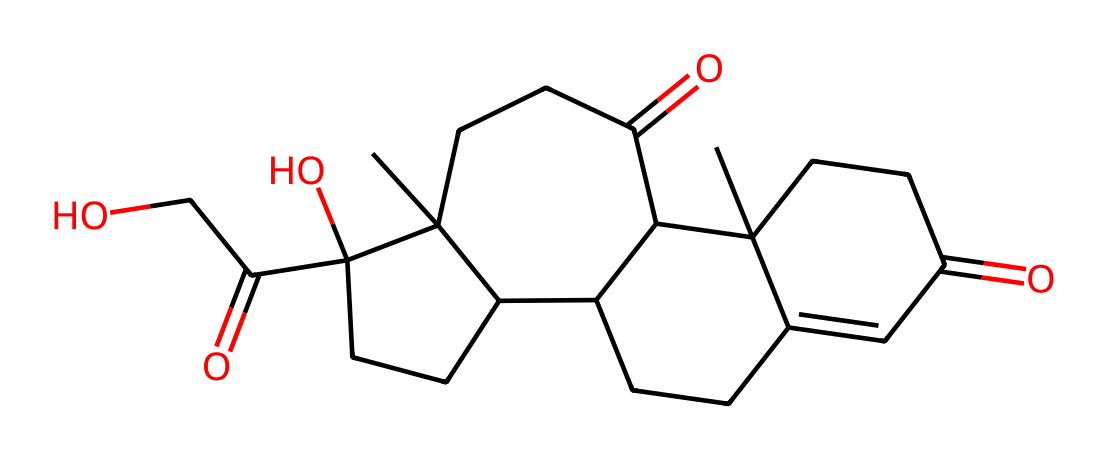What is the name of this chemical? The chemical structure represented by the provided SMILES corresponds to cortisol, which is known as a glucocorticoid hormone.
Answer: cortisol How many carbon atoms are present in the structure? By analyzing the SMILES, we can count that there are 21 carbon (C) atoms present in the structure of cortisol.
Answer: 21 What type of chemical compound is cortisol? Cortisol is classified as a steroid hormone due to its specific structural features, including its four fused carbon rings.
Answer: steroid hormone What functional groups are present in cortisol? The structure features a ketone group (indicated by the =O) and hydroxyl groups (–OH) that contribute to its properties as a hormone.
Answer: ketone and hydroxyl How many oxygen atoms are in cortisol? Counting the oxygen (O) atoms in the structure, we find that there are 5 oxygen atoms in total.
Answer: 5 How does cortisol affect user behavior? Cortisol regulates metabolism and influences stress responses, which can impact mood and behavior, particularly in stressful situations.
Answer: mood and behavior What is the molecular formula for cortisol? After analyzing the molecular structure, we can derive the molecular formula as C21H30O5, indicating the ratio of carbon, hydrogen, and oxygen atoms.
Answer: C21H30O5 